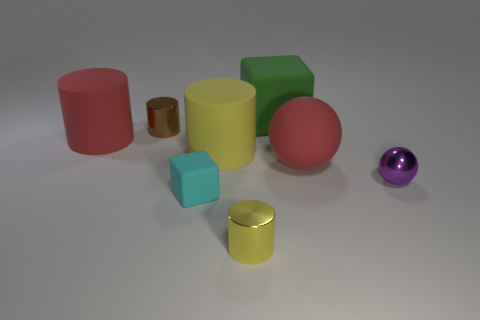Are there any repeating shapes among the objects? Yes, there are two spheres, two cubes, and three cylinders, indicating a repetition of shapes in different sizes and colors. 